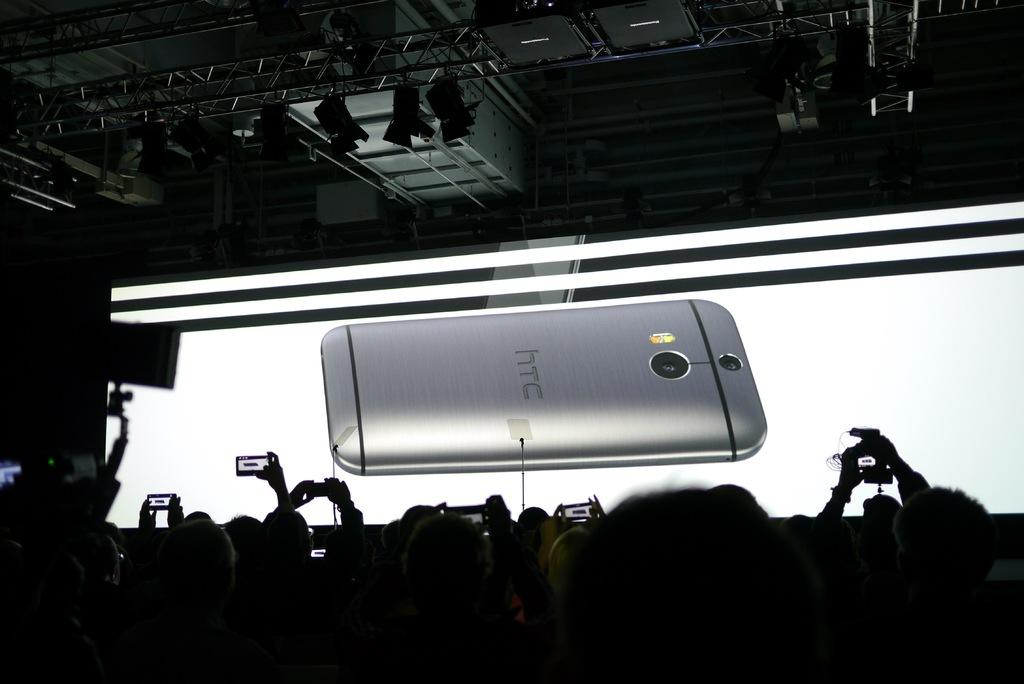<image>
Relay a brief, clear account of the picture shown. A smartphone from HTC is placed on a brightly lit desk face down. 